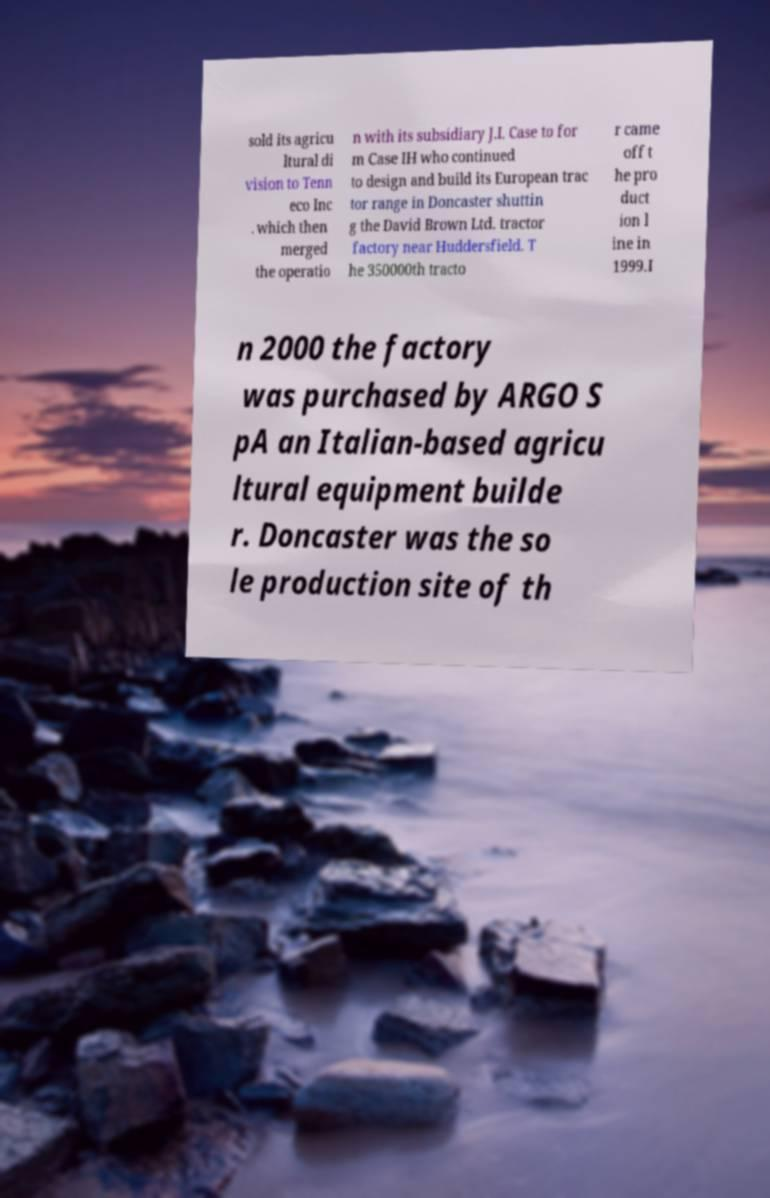For documentation purposes, I need the text within this image transcribed. Could you provide that? sold its agricu ltural di vision to Tenn eco Inc . which then merged the operatio n with its subsidiary J.I. Case to for m Case IH who continued to design and build its European trac tor range in Doncaster shuttin g the David Brown Ltd. tractor factory near Huddersfield. T he 350000th tracto r came off t he pro duct ion l ine in 1999.I n 2000 the factory was purchased by ARGO S pA an Italian-based agricu ltural equipment builde r. Doncaster was the so le production site of th 